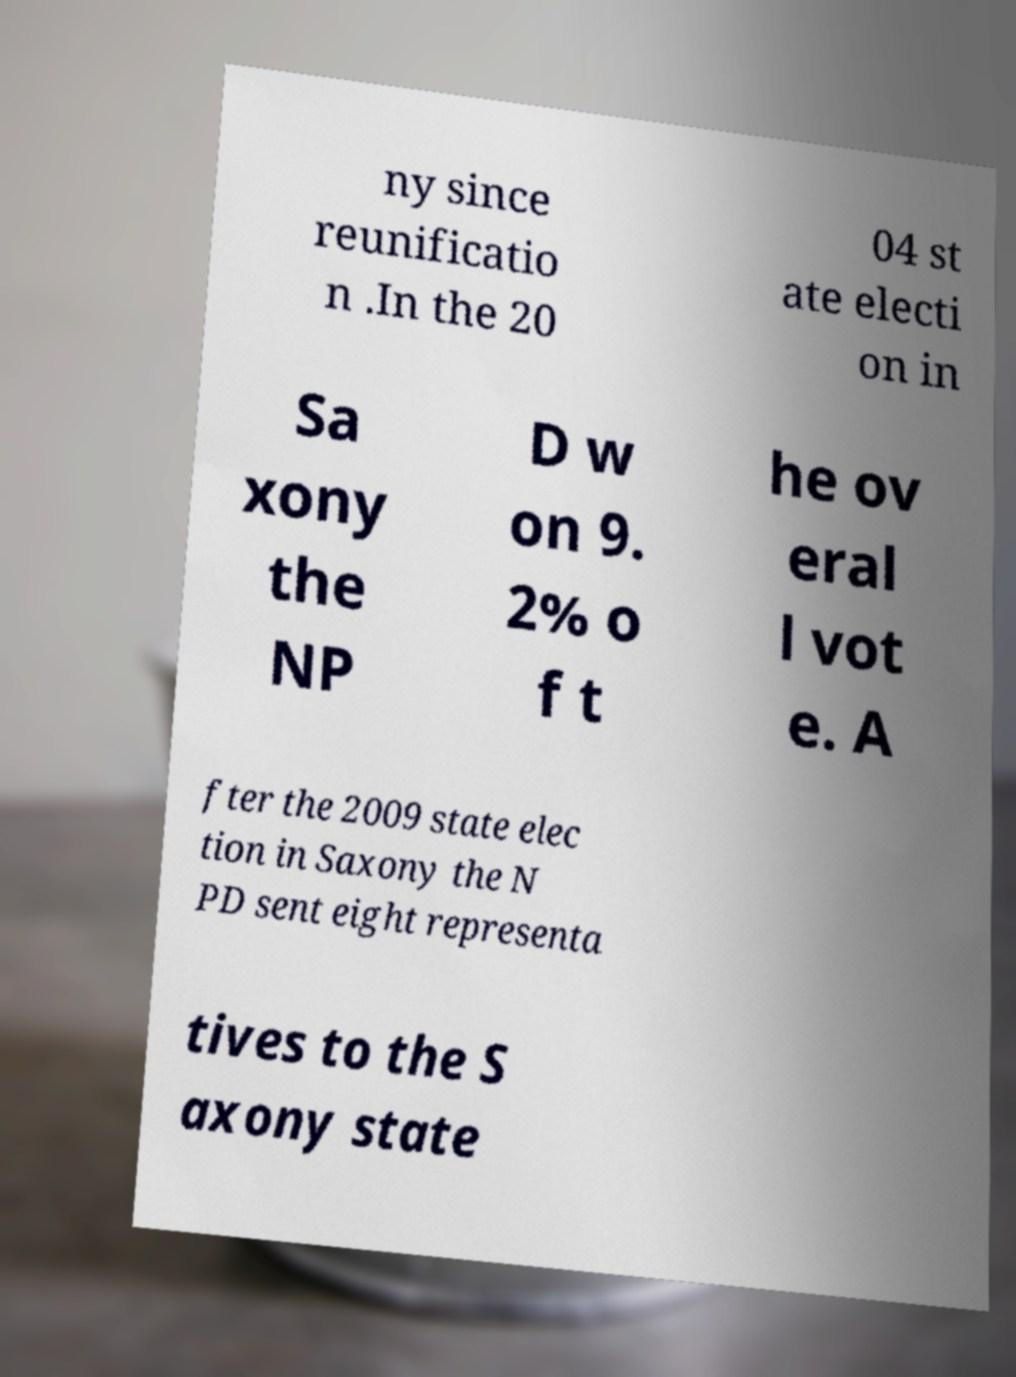Please read and relay the text visible in this image. What does it say? ny since reunificatio n .In the 20 04 st ate electi on in Sa xony the NP D w on 9. 2% o f t he ov eral l vot e. A fter the 2009 state elec tion in Saxony the N PD sent eight representa tives to the S axony state 